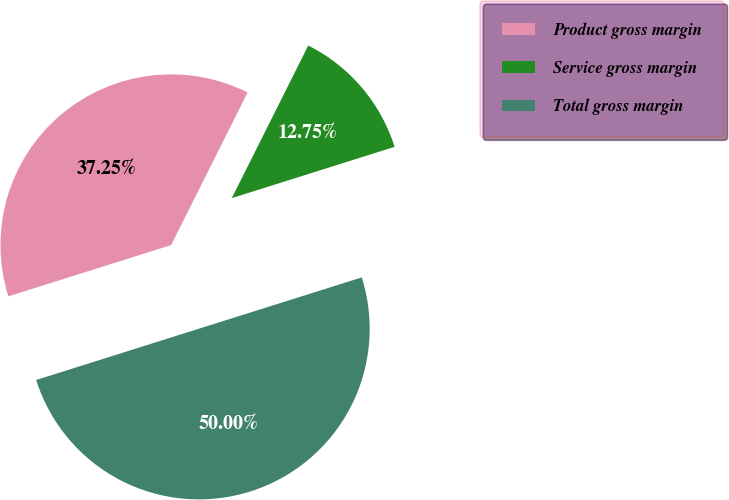Convert chart. <chart><loc_0><loc_0><loc_500><loc_500><pie_chart><fcel>Product gross margin<fcel>Service gross margin<fcel>Total gross margin<nl><fcel>37.25%<fcel>12.75%<fcel>50.0%<nl></chart> 